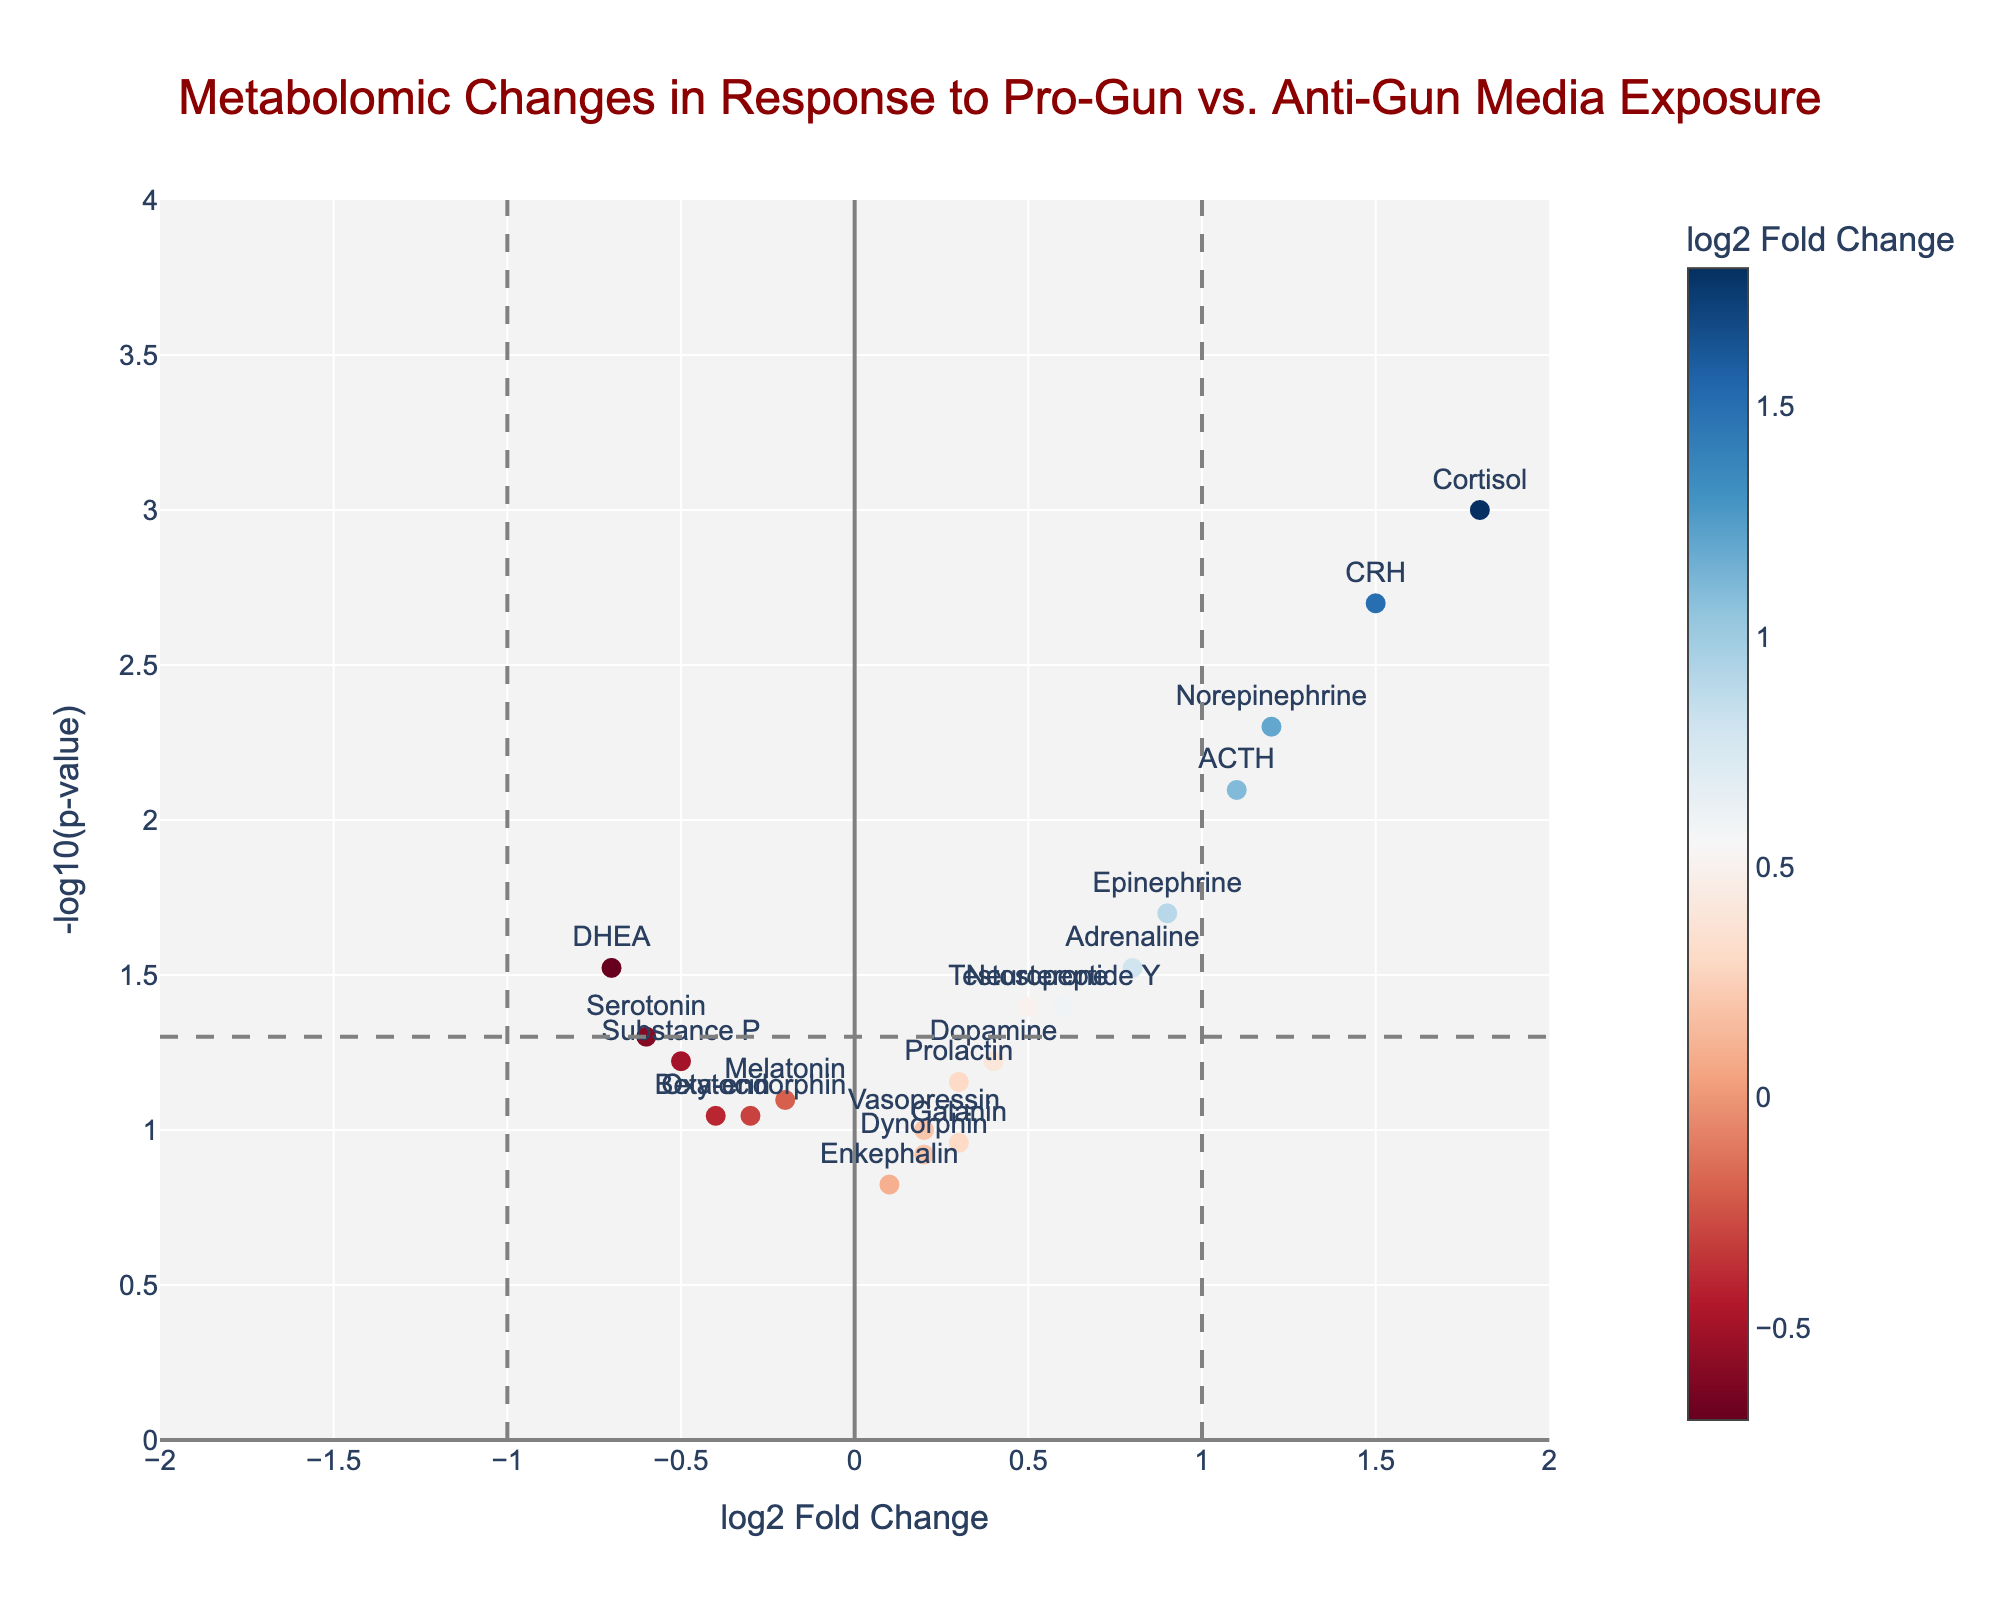How many metabolites show a significant response (p-value < 0.05)? To determine how many metabolites are significant, we look for points above the horizontal line at -log10(0.05) = 1.3. There are 6 such points above this line
Answer: 6 Which metabolite has the highest log2 Fold Change? To find the metabolite with the highest log2 Fold Change, we locate the rightmost point on the x-axis. This point is labeled as Cortisol with a log2 Fold Change of 1.8
Answer: Cortisol Which metabolites are significantly downregulated (also have a log2 Fold Change < -0.7)? Downregulated metabolites are those with log2 Fold Change < 0. To identify significant ones, we look for points above the horizontal line (p-value < 0.05) and left of the vertical line x = -0.7. The metabolite DHEA is the only one satisfying both conditions
Answer: DHEA What does the horizontal line at y = 1.3 represent in the plot? The horizontal line at y = 1.3 represents the threshold for significance at p-value < 0.05 since -log10(0.05) = 1.3. Points above this line have p-values less than 0.05 and are considered significant
Answer: Significance threshold Which metabolite has the lowest p-value? To find the metabolite with the lowest p-value, we identify the point highest on the y-axis. This point corresponds to the lowest p-value, which is the Cortisol
Answer: Cortisol What are the log2 Fold Change and p-values of CRH? To find information about CRH, we locate the corresponding point on the plot. The hover information or text labels give us a log2 Fold Change of 1.5 and a p-value of 0.002
Answer: 1.5 and 0.002 How many metabolites show a non-significant response (p-value >= 0.05)? To find non-significant metabolites, we count the points below the horizontal line at -log10(0.05) = 1.3. There are 13 such points in the plot
Answer: 13 